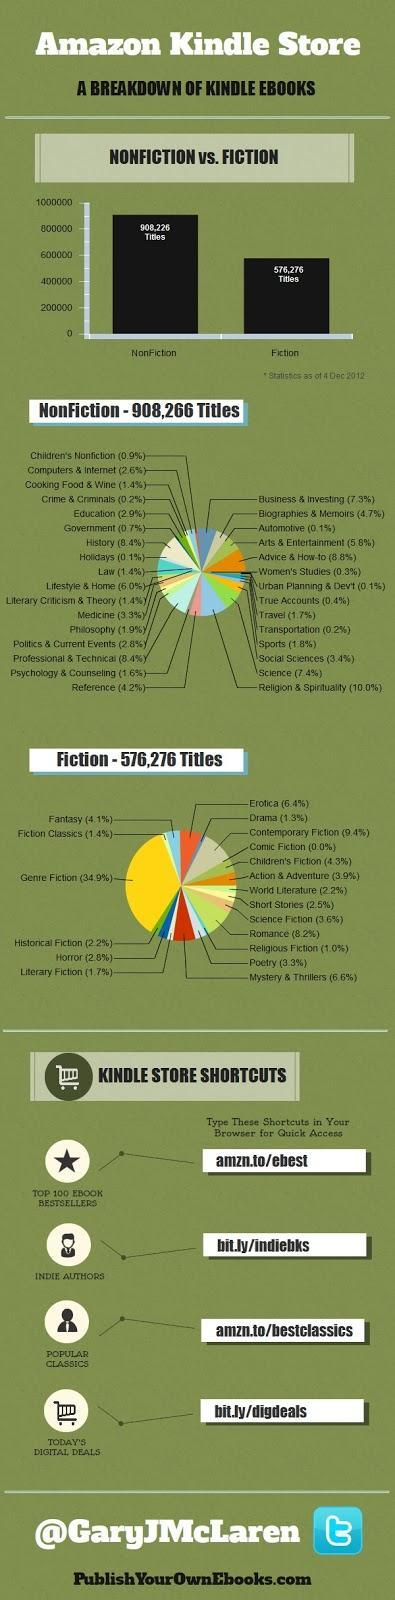Which fiction genre had the second highest percentage of books written?
Answer the question with a short phrase. Contemporary Fiction Which non-fiction genre had the lowest percentage of books written? Automotive, Urban Planning & Dev't Which non-fiction genre had the highest percentage of books written? Advice & How-to How many more titles of non-fiction was sold in 2012 in comparison to fiction? 331,950 